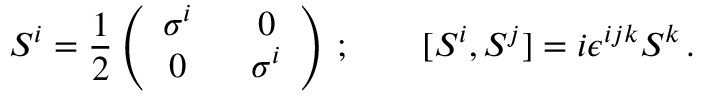<formula> <loc_0><loc_0><loc_500><loc_500>S ^ { i } = { \frac { 1 } { 2 } } \left ( \begin{array} { c c } { { \sigma ^ { i } } } & { 0 } \\ { 0 } & { { \sigma ^ { i } } } \end{array} \right ) \, ; \quad [ S ^ { i } , S ^ { j } ] = i \epsilon ^ { i j k } S ^ { k } \, .</formula> 